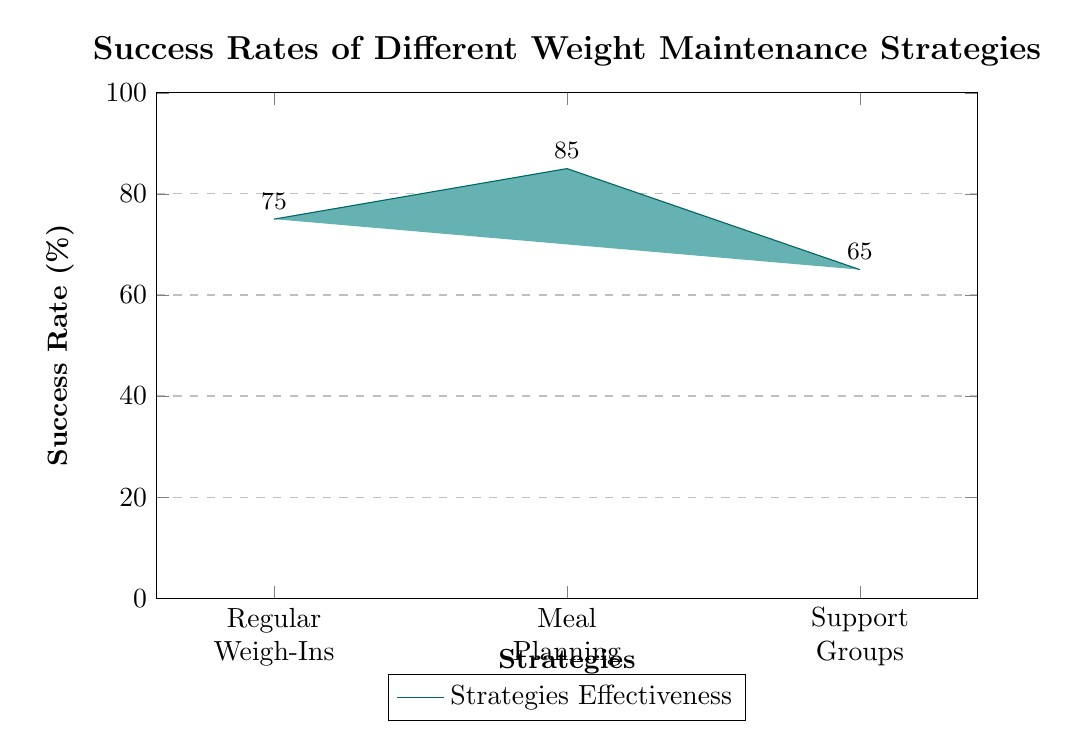What is the success rate for Regular Weigh-Ins? The diagram shows the success rate for Regular Weigh-Ins as the first bar, which indicates a value of 75%.
Answer: 75% What is the highest success rate among the strategies? The bars represent success rates, and by comparing the heights, Meal Planning has the highest value at 85%.
Answer: 85% What success rate corresponds to Support Groups? Looking at the third bar labeled Support Groups, it displays a success rate of 65%.
Answer: 65% Which strategy has the lowest success rate? By examining the height of the bars, Support Groups has the shortest bar, indicating it has the lowest success rate compared to the other strategies.
Answer: Support Groups What information does the node near the Regular Weigh-Ins bar provide? The node below the Regular Weigh-Ins bar states "Helps track progress," identifying the benefit of this strategy.
Answer: Helps track progress Which strategy is noted for ensuring a balanced diet? The node below the Meal Planning bar explicitly mentions "Ensures balanced diet," which indicates its primary role.
Answer: Ensures balanced diet What do the values on the Y-axis represent? The Y-axis values range from 0 to 100 and indicate the percentage for the success rates of the different strategies.
Answer: Success Rate (%) How many different weight maintenance strategies are displayed in the diagram? The diagram highlights three strategies: Regular Weigh-Ins, Meal Planning, and Support Groups, so the total count is three.
Answer: Three Which bar represents Meal Planning? The second bar in the diagram corresponds to Meal Planning, as identified by its position labeled in the x-tick labels.
Answer: Second Bar What type of chart is used to display the success rates? The diagram is a bar chart, as indicated by the vertical bars representing different strategies and their success rates.
Answer: Bar chart 